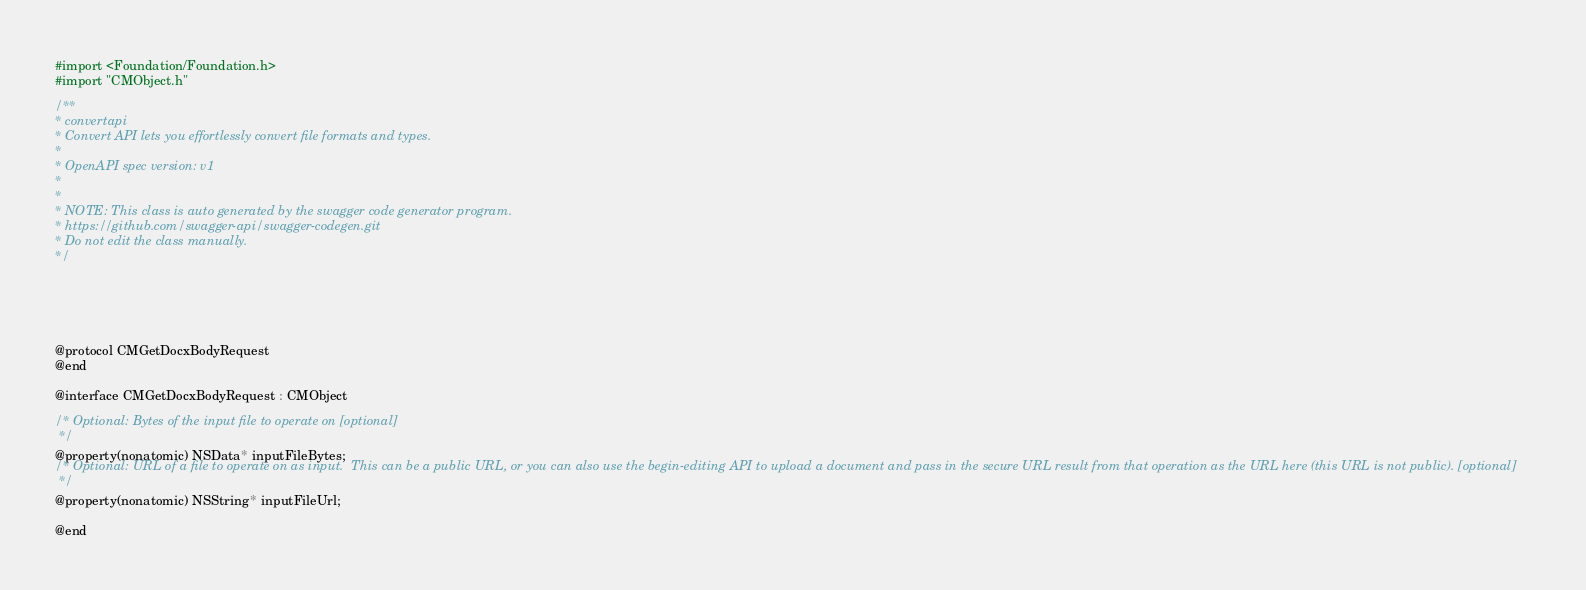<code> <loc_0><loc_0><loc_500><loc_500><_C_>#import <Foundation/Foundation.h>
#import "CMObject.h"

/**
* convertapi
* Convert API lets you effortlessly convert file formats and types.
*
* OpenAPI spec version: v1
* 
*
* NOTE: This class is auto generated by the swagger code generator program.
* https://github.com/swagger-api/swagger-codegen.git
* Do not edit the class manually.
*/





@protocol CMGetDocxBodyRequest
@end

@interface CMGetDocxBodyRequest : CMObject

/* Optional: Bytes of the input file to operate on [optional]
 */
@property(nonatomic) NSData* inputFileBytes;
/* Optional: URL of a file to operate on as input.  This can be a public URL, or you can also use the begin-editing API to upload a document and pass in the secure URL result from that operation as the URL here (this URL is not public). [optional]
 */
@property(nonatomic) NSString* inputFileUrl;

@end
</code> 